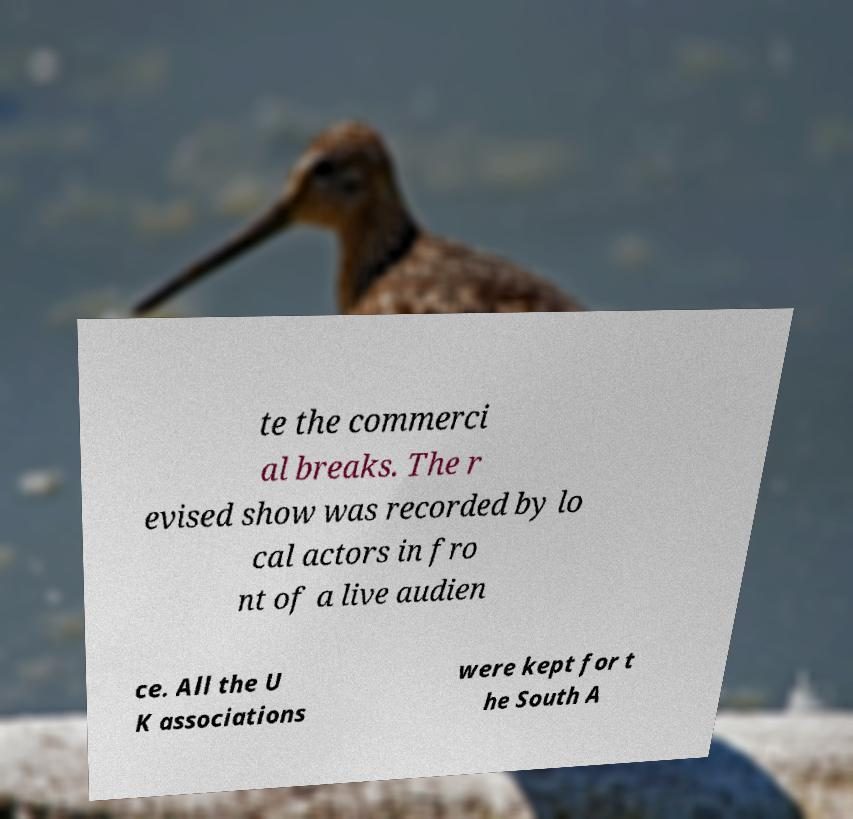Could you assist in decoding the text presented in this image and type it out clearly? te the commerci al breaks. The r evised show was recorded by lo cal actors in fro nt of a live audien ce. All the U K associations were kept for t he South A 